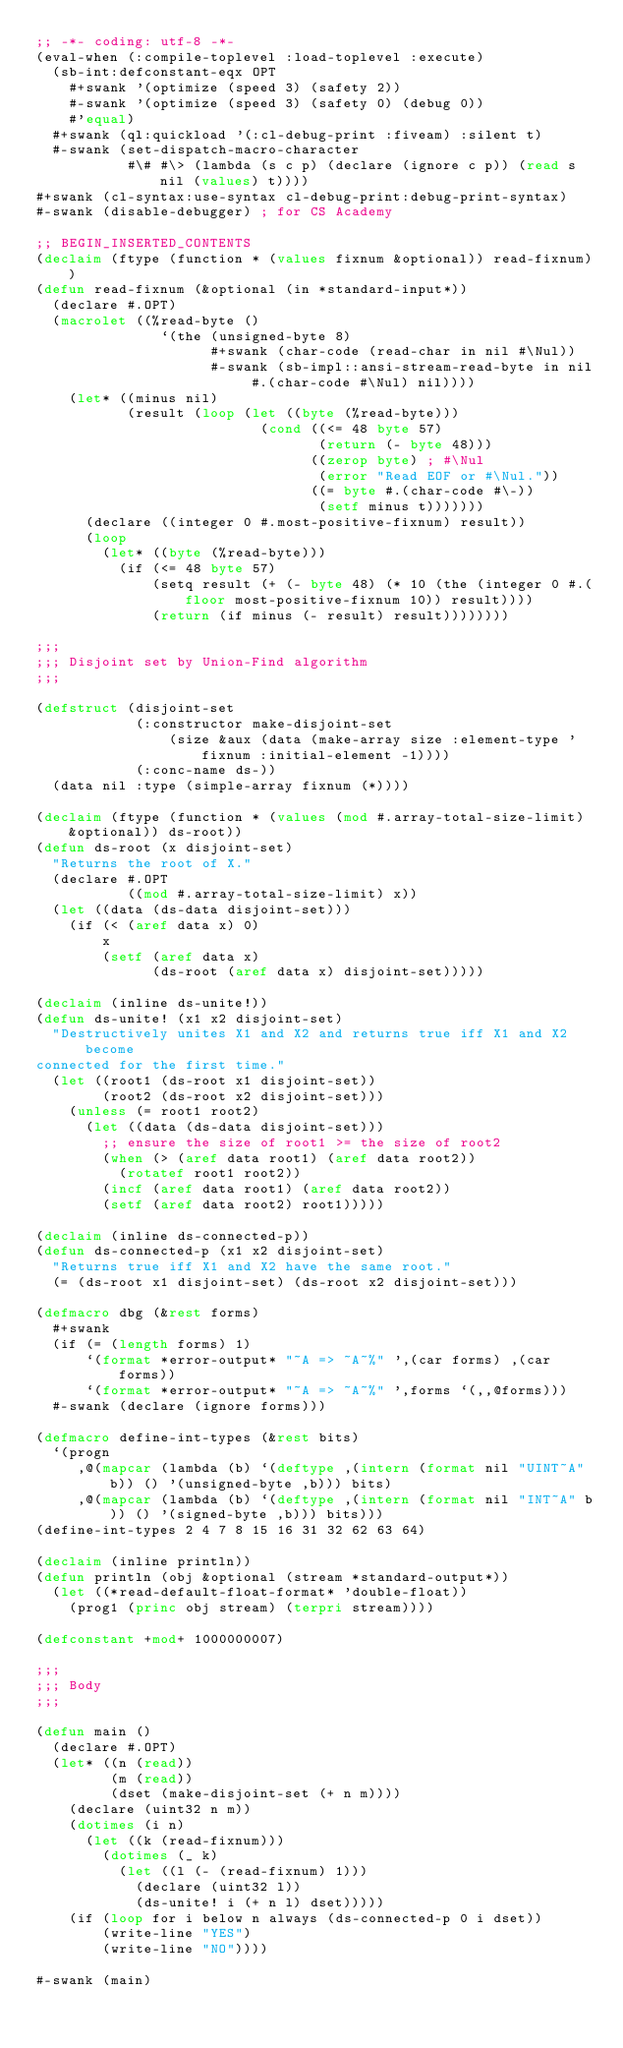<code> <loc_0><loc_0><loc_500><loc_500><_Lisp_>;; -*- coding: utf-8 -*-
(eval-when (:compile-toplevel :load-toplevel :execute)
  (sb-int:defconstant-eqx OPT
    #+swank '(optimize (speed 3) (safety 2))
    #-swank '(optimize (speed 3) (safety 0) (debug 0))
    #'equal)
  #+swank (ql:quickload '(:cl-debug-print :fiveam) :silent t)
  #-swank (set-dispatch-macro-character
           #\# #\> (lambda (s c p) (declare (ignore c p)) (read s nil (values) t))))
#+swank (cl-syntax:use-syntax cl-debug-print:debug-print-syntax)
#-swank (disable-debugger) ; for CS Academy

;; BEGIN_INSERTED_CONTENTS
(declaim (ftype (function * (values fixnum &optional)) read-fixnum))
(defun read-fixnum (&optional (in *standard-input*))
  (declare #.OPT)
  (macrolet ((%read-byte ()
               `(the (unsigned-byte 8)
                     #+swank (char-code (read-char in nil #\Nul))
                     #-swank (sb-impl::ansi-stream-read-byte in nil #.(char-code #\Nul) nil))))
    (let* ((minus nil)
           (result (loop (let ((byte (%read-byte)))
                           (cond ((<= 48 byte 57)
                                  (return (- byte 48)))
                                 ((zerop byte) ; #\Nul
                                  (error "Read EOF or #\Nul."))
                                 ((= byte #.(char-code #\-))
                                  (setf minus t)))))))
      (declare ((integer 0 #.most-positive-fixnum) result))
      (loop
        (let* ((byte (%read-byte)))
          (if (<= 48 byte 57)
              (setq result (+ (- byte 48) (* 10 (the (integer 0 #.(floor most-positive-fixnum 10)) result))))
              (return (if minus (- result) result))))))))

;;;
;;; Disjoint set by Union-Find algorithm
;;;

(defstruct (disjoint-set
            (:constructor make-disjoint-set
                (size &aux (data (make-array size :element-type 'fixnum :initial-element -1))))
            (:conc-name ds-))
  (data nil :type (simple-array fixnum (*))))

(declaim (ftype (function * (values (mod #.array-total-size-limit) &optional)) ds-root))
(defun ds-root (x disjoint-set)
  "Returns the root of X."
  (declare #.OPT
           ((mod #.array-total-size-limit) x))
  (let ((data (ds-data disjoint-set)))
    (if (< (aref data x) 0)
        x
        (setf (aref data x)
              (ds-root (aref data x) disjoint-set)))))

(declaim (inline ds-unite!))
(defun ds-unite! (x1 x2 disjoint-set)
  "Destructively unites X1 and X2 and returns true iff X1 and X2 become
connected for the first time."
  (let ((root1 (ds-root x1 disjoint-set))
        (root2 (ds-root x2 disjoint-set)))
    (unless (= root1 root2)
      (let ((data (ds-data disjoint-set)))
        ;; ensure the size of root1 >= the size of root2
        (when (> (aref data root1) (aref data root2))
          (rotatef root1 root2))
        (incf (aref data root1) (aref data root2))
        (setf (aref data root2) root1)))))

(declaim (inline ds-connected-p))
(defun ds-connected-p (x1 x2 disjoint-set)
  "Returns true iff X1 and X2 have the same root."
  (= (ds-root x1 disjoint-set) (ds-root x2 disjoint-set)))

(defmacro dbg (&rest forms)
  #+swank
  (if (= (length forms) 1)
      `(format *error-output* "~A => ~A~%" ',(car forms) ,(car forms))
      `(format *error-output* "~A => ~A~%" ',forms `(,,@forms)))
  #-swank (declare (ignore forms)))

(defmacro define-int-types (&rest bits)
  `(progn
     ,@(mapcar (lambda (b) `(deftype ,(intern (format nil "UINT~A" b)) () '(unsigned-byte ,b))) bits)
     ,@(mapcar (lambda (b) `(deftype ,(intern (format nil "INT~A" b)) () '(signed-byte ,b))) bits)))
(define-int-types 2 4 7 8 15 16 31 32 62 63 64)

(declaim (inline println))
(defun println (obj &optional (stream *standard-output*))
  (let ((*read-default-float-format* 'double-float))
    (prog1 (princ obj stream) (terpri stream))))

(defconstant +mod+ 1000000007)

;;;
;;; Body
;;;

(defun main ()
  (declare #.OPT)
  (let* ((n (read))
         (m (read))
         (dset (make-disjoint-set (+ n m))))
    (declare (uint32 n m))
    (dotimes (i n)
      (let ((k (read-fixnum)))
        (dotimes (_ k)
          (let ((l (- (read-fixnum) 1)))
            (declare (uint32 l))
            (ds-unite! i (+ n l) dset)))))
    (if (loop for i below n always (ds-connected-p 0 i dset))
        (write-line "YES")
        (write-line "NO"))))

#-swank (main)
</code> 